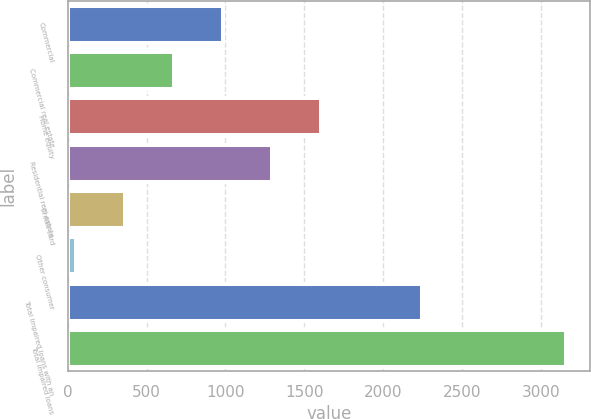Convert chart. <chart><loc_0><loc_0><loc_500><loc_500><bar_chart><fcel>Commercial<fcel>Commercial real estate<fcel>Home equity<fcel>Residential real estate<fcel>Credit card<fcel>Other consumer<fcel>Total impaired loans with an<fcel>Total impaired loans<nl><fcel>982.8<fcel>672.2<fcel>1604<fcel>1293.4<fcel>361.6<fcel>51<fcel>2249<fcel>3157<nl></chart> 